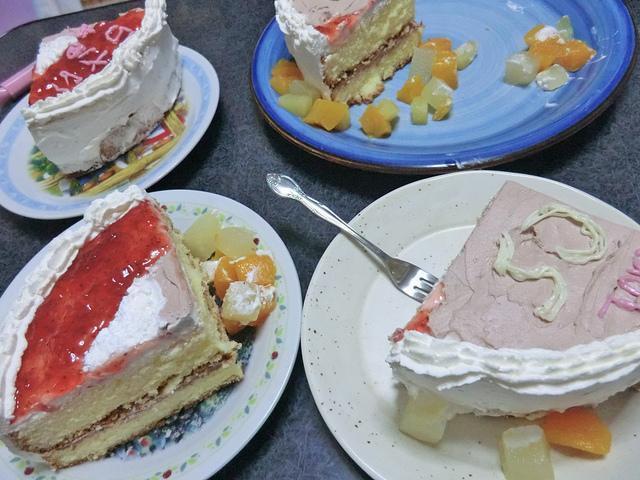How many plates have a fork?
Give a very brief answer. 1. How many cakes are there?
Give a very brief answer. 4. 